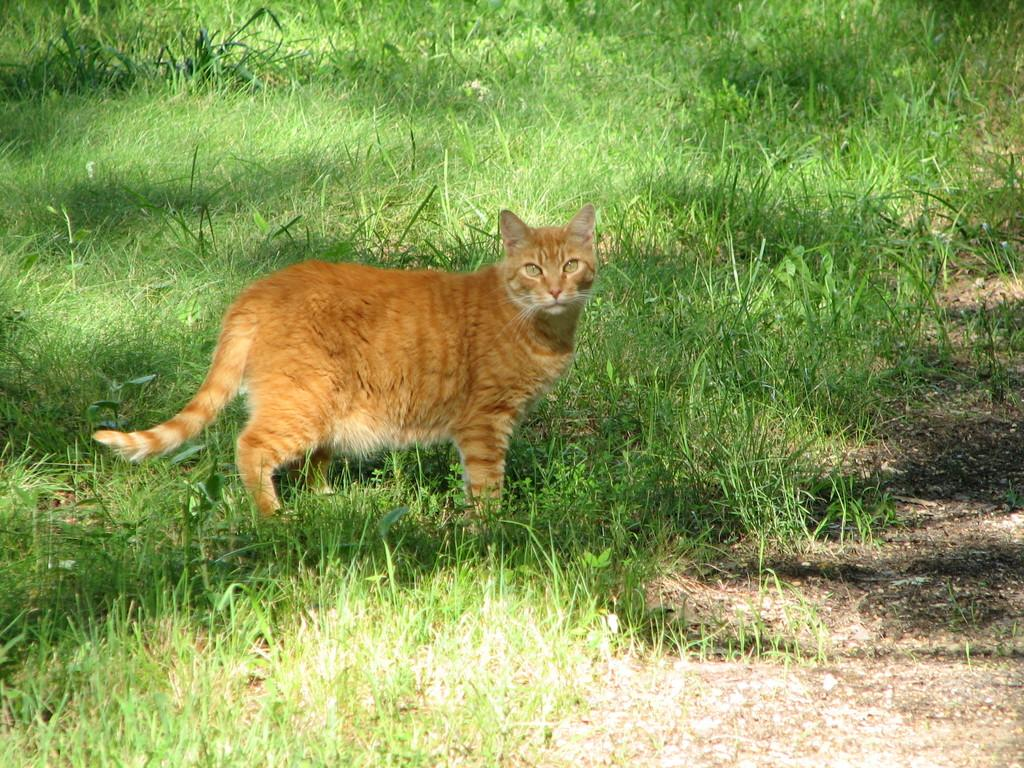What type of animal is in the image? There is a cat in the image. Where is the cat located in the image? The cat is on the left side of the image. What type of environment is visible on the left side of the image? There is grassland on the left side of the image. What is the rate of growth for the cat in the image? The image does not provide information about the cat's growth rate. --- 